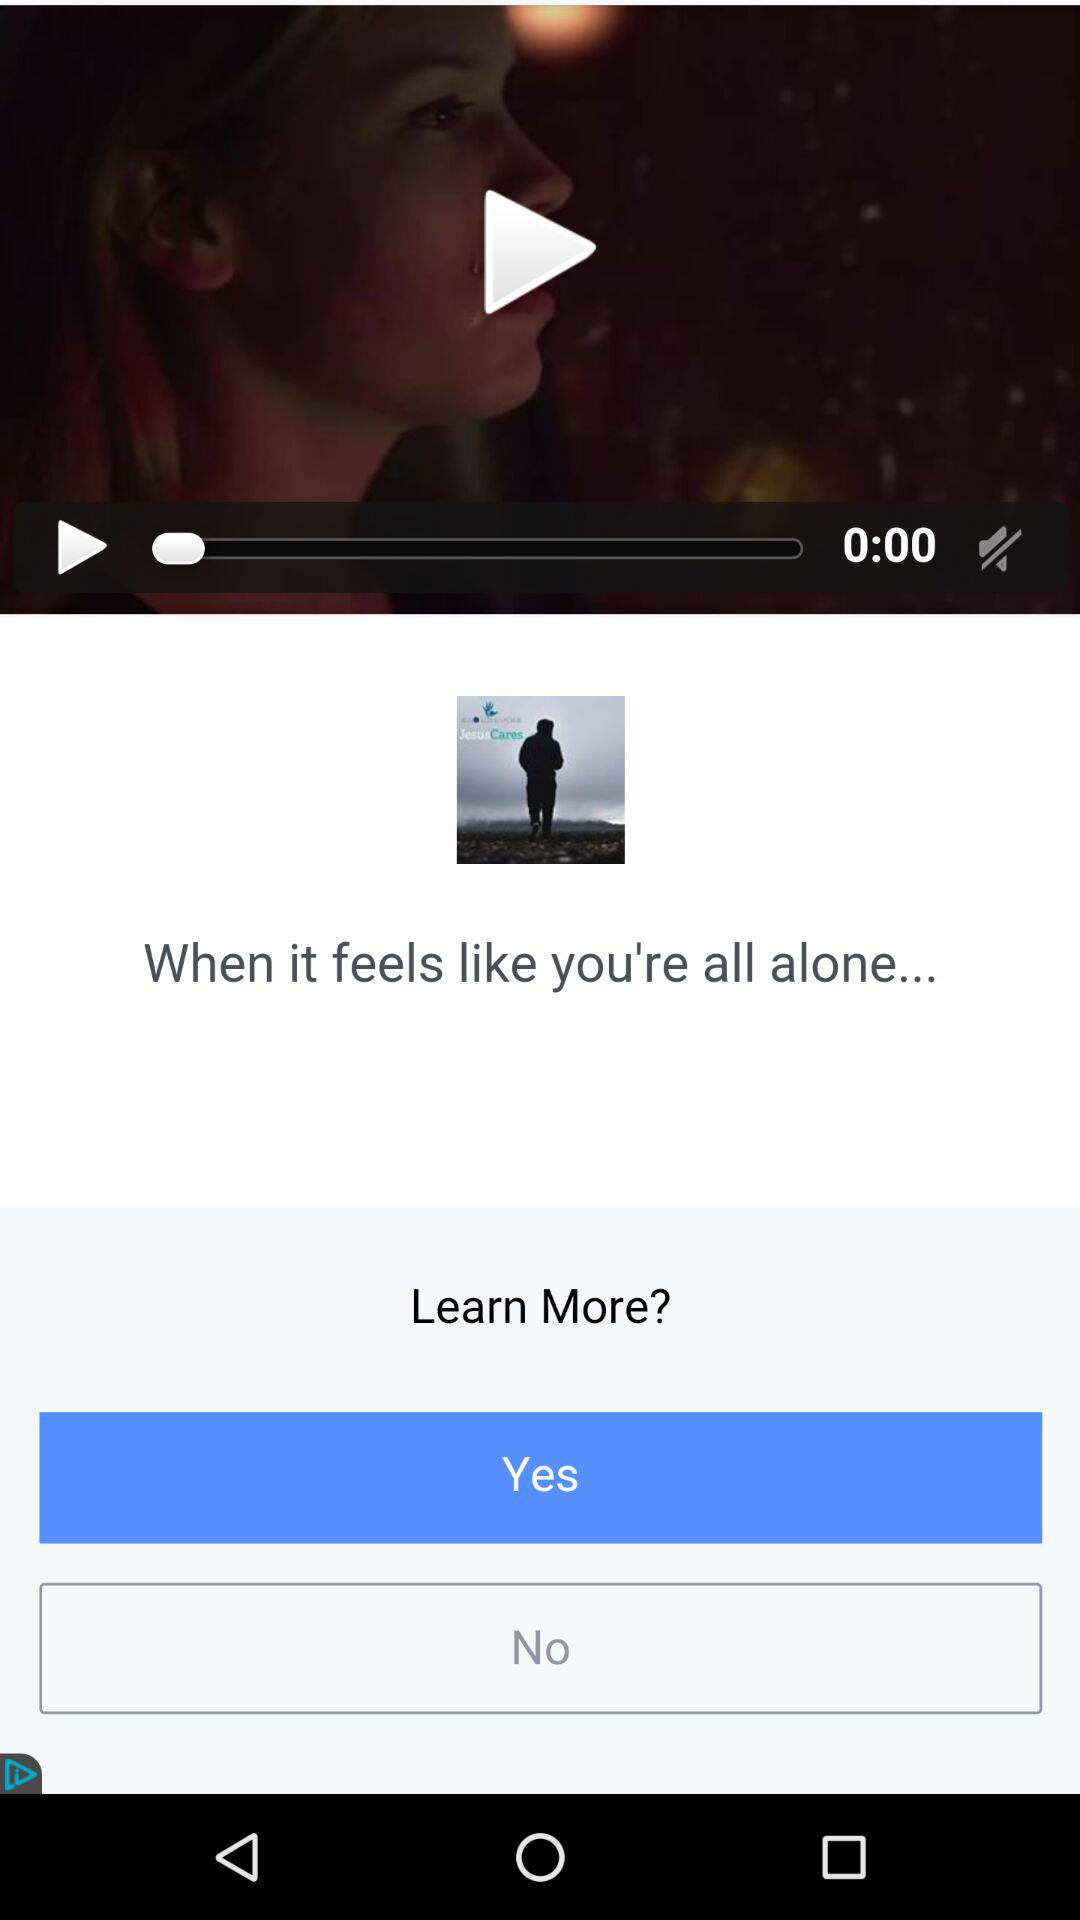How many seconds is the video?
Answer the question using a single word or phrase. 0 